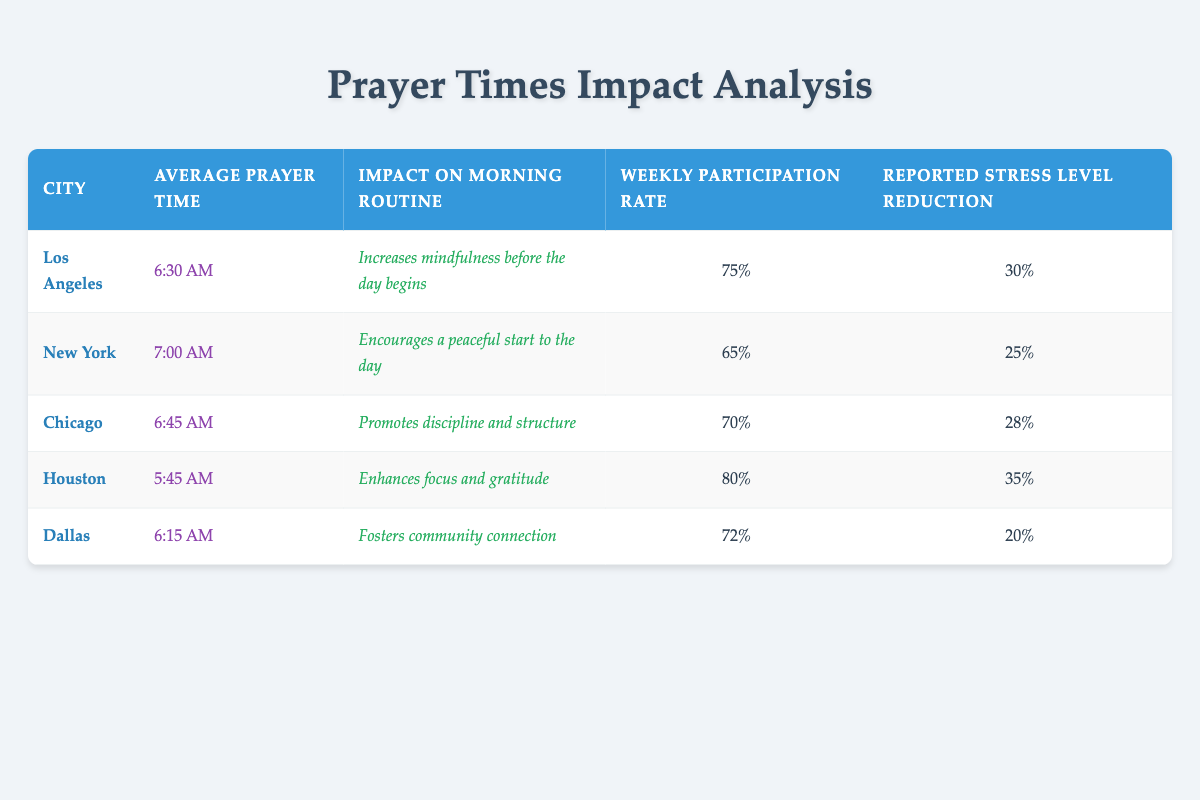What is the average prayer time in Chicago? The table lists the average prayer time for Chicago as 6:45 AM. This is directly referenced from the data provided in the "Average Prayer Time" column for the city of Chicago.
Answer: 6:45 AM Which city has the highest reported stress level reduction? By examining the "Reported Stress Level Reduction" column, it can be seen that Houston has a reported reduction of 35, which is higher than all other cities listed.
Answer: Houston What is the weekly participation rate for New York? The weekly participation rate for New York is stated as 65% in the "Weekly Participation Rate" column of the table. This is a straightforward retrieval question based on the data for New York.
Answer: 65 Which city shows an impact on morning routine that emphasizes mindfulness? The impact description for Los Angeles states "Increases mindfulness before the day begins," indicating that it specifically emphasizes mindfulness. This can be found in the "Impact on Morning Routine" column for Los Angeles.
Answer: Los Angeles Calculate the average reported stress level reduction across all cities. The reported stress levels are 30, 25, 28, 35, and 20 for Los Angeles, New York, Chicago, Houston, and Dallas respectively. First, sum these values: 30 + 25 + 28 + 35 + 20 = 138. Then, divide by the number of cities, which is 5. So, the average is 138 / 5 = 27.6.
Answer: 27.6 Is the average prayer time in Houston earlier than in Dallas? Houston's average prayer time is 5:45 AM, while Dallas's average prayer time is 6:15 AM. Since 5:45 AM is earlier than 6:15 AM, the answer to this question is yes.
Answer: Yes Which city has the lowest weekly participation rate? By reviewing the "Weekly Participation Rate" column, New York has the lowest rate at 65% compared to the other cities. This is determined by comparing each city's rate.
Answer: New York What percentage of participants in Houston reported a stress level reduction of 35? Houston's reported stress level reduction is explicitly stated as 35%. Therefore, the percentage of participants who reported this reduction is 35%. This is a direct retrieval from the data provided.
Answer: 35 Explain whether the average prayer time correlates with the reported stress level reduction in any city. To check for correlation, we would look if cities with earlier average prayer times also have higher reported stress level reductions. The data reveals Houston, which has the earliest prayer time at 5:45 AM, correlates with the highest stress reduction (35%). In contrast, New York has a later prayer time (7:00 AM) and a lower reduction (25%). Thus, there seems to be a relationship where earlier prayer times might relate to higher stress reduction in these cases.
Answer: Yes, there is a correlation 